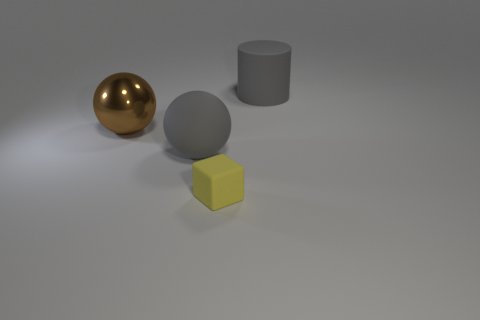Add 3 big gray matte blocks. How many objects exist? 7 Subtract all blocks. How many objects are left? 3 Add 2 big cylinders. How many big cylinders exist? 3 Subtract 0 blue blocks. How many objects are left? 4 Subtract all gray cylinders. Subtract all gray matte things. How many objects are left? 1 Add 3 big gray matte balls. How many big gray matte balls are left? 4 